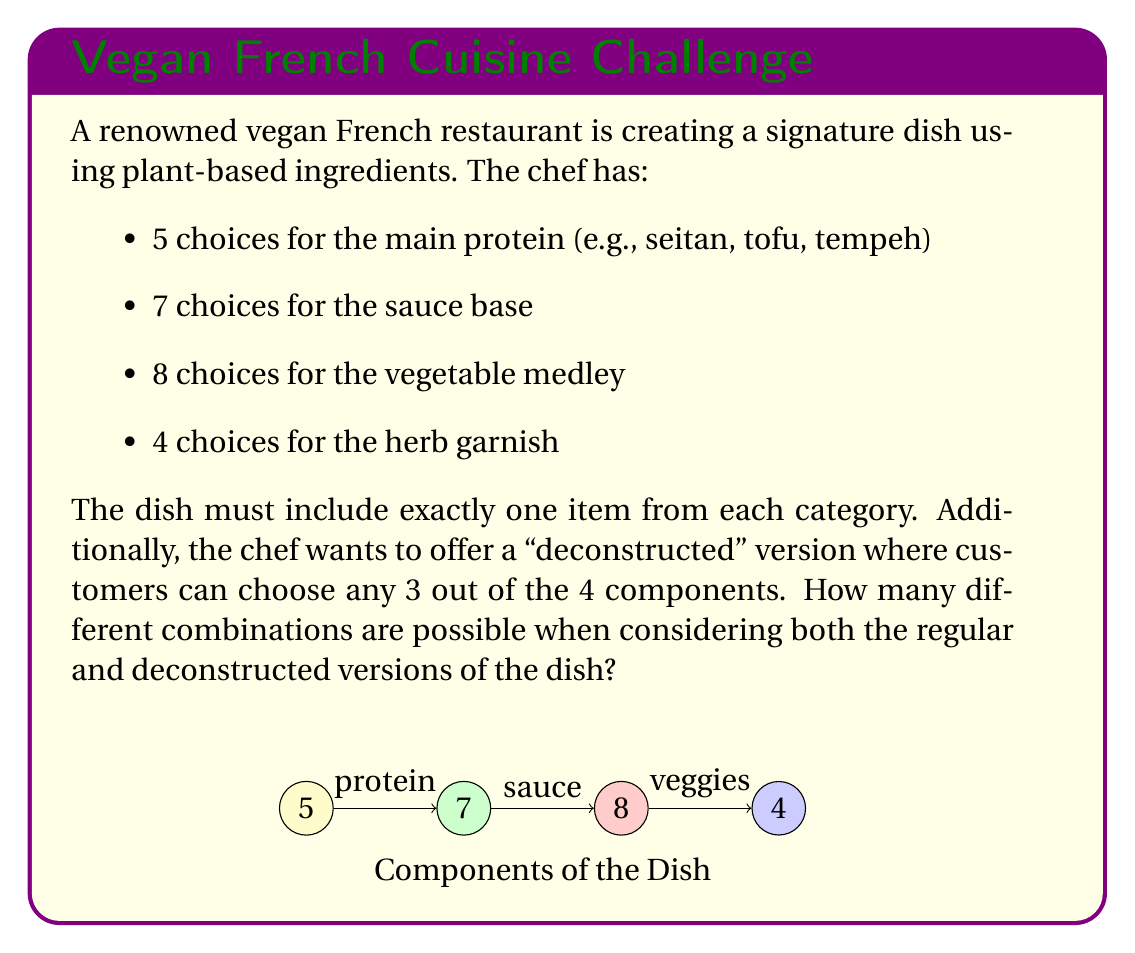Show me your answer to this math problem. Let's approach this step-by-step:

1) First, let's calculate the number of combinations for the regular dish:
   $$5 \times 7 \times 8 \times 4 = 1120$$ combinations

2) For the deconstructed version, we need to calculate the number of ways to choose 3 components out of 4, and then the number of combinations within those 3 components.

3) The number of ways to choose 3 components out of 4 is given by the combination formula:
   $$\binom{4}{3} = \frac{4!}{3!(4-3)!} = \frac{4 \times 3 \times 2 \times 1}{(3 \times 2 \times 1)(1)} = 4$$ ways

4) Now, for each of these 4 ways, we need to calculate the number of combinations:
   - Protein, Sauce, Vegetable: $5 \times 7 \times 8 = 280$
   - Protein, Sauce, Herb: $5 \times 7 \times 4 = 140$
   - Protein, Vegetable, Herb: $5 \times 8 \times 4 = 160$
   - Sauce, Vegetable, Herb: $7 \times 8 \times 4 = 224$

5) The total number of deconstructed combinations is:
   $$280 + 140 + 160 + 224 = 804$$

6) The final answer is the sum of regular and deconstructed combinations:
   $$1120 + 804 = 1924$$ total combinations
Answer: 1924 